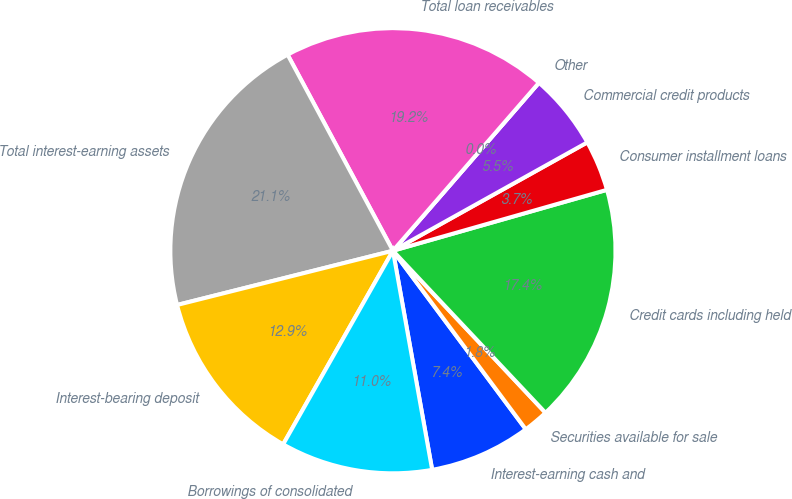<chart> <loc_0><loc_0><loc_500><loc_500><pie_chart><fcel>Interest-earning cash and<fcel>Securities available for sale<fcel>Credit cards including held<fcel>Consumer installment loans<fcel>Commercial credit products<fcel>Other<fcel>Total loan receivables<fcel>Total interest-earning assets<fcel>Interest-bearing deposit<fcel>Borrowings of consolidated<nl><fcel>7.36%<fcel>1.84%<fcel>17.39%<fcel>3.68%<fcel>5.52%<fcel>0.0%<fcel>19.23%<fcel>21.07%<fcel>12.87%<fcel>11.03%<nl></chart> 